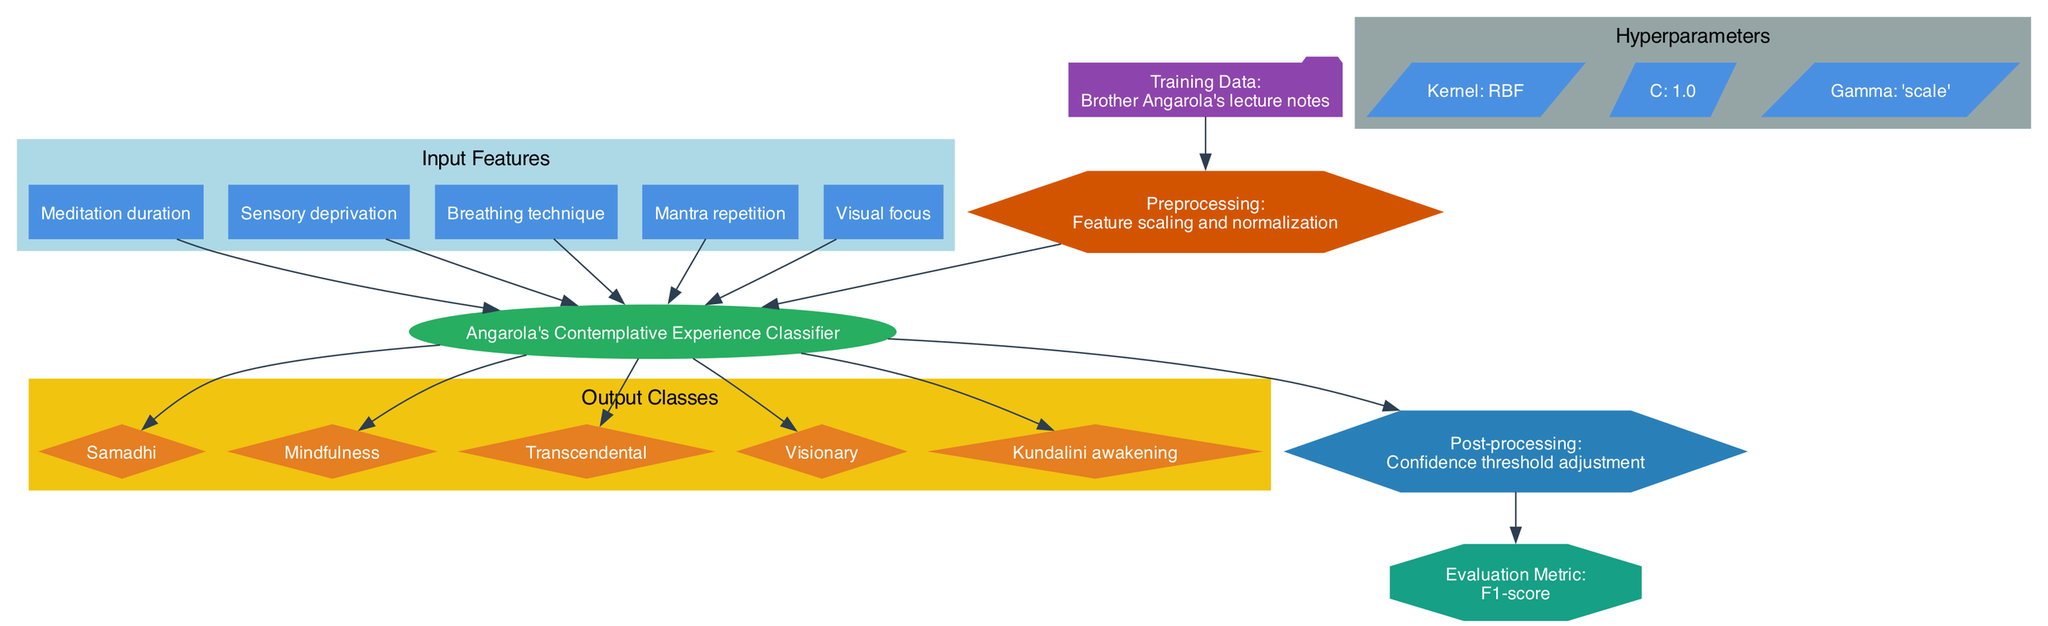What are the input features for the SVM model? The input features are provided in a cluster labeled "Input Features", which includes: Meditation duration, Sensory deprivation, Breathing technique, Mantra repetition, and Visual focus.
Answer: Meditation duration, Sensory deprivation, Breathing technique, Mantra repetition, Visual focus What is the evaluation metric used in this model? In the diagram, there is a node labeled "Evaluation Metric", which specifies that the model uses the F1-score to evaluate its performance.
Answer: F1-score How many output classes does the SVM classify? The "Output Classes" subgraph shows five distinct classes: Samadhi, Mindfulness, Transcendental, Visionary, and Kundalini awakening. Counting these gives a total of five output classes.
Answer: Five Which kernel is used in the hyperparameters? There is a node in the "Hyperparameters" section labeled "Kernel" which states that the RBF kernel is used in this SVM model.
Answer: RBF What is the flow from training data to the evaluation metric? The flow starts from the "Training Data" node, connecting to "Preprocessing", which leads to the "SVM" node. From there, it directs to "Post-processing", and finally connects to the "Evaluation Metric". This sequence describes how data moves and is processed to evaluate model performance.
Answer: Training Data -> Preprocessing -> SVM -> Post-processing -> Evaluation Metric What type of model is represented in this diagram? The model labeled "Angarola's Contemplative Experience Classifier" is identified as a support vector machine (SVM) model, which is a type of supervised machine learning model.
Answer: Support vector machine Which post-processing step is mentioned in the diagram? The "Post-processing" node in the diagram specifies "Confidence threshold adjustment" as the process involved after the SVM classification.
Answer: Confidence threshold adjustment How many hyperparameters are identified in the diagram? Under the "Hyperparameters" cluster, three specific hyperparameters are listed: Kernel, C, and Gamma. This indicates that there are three hyperparameters defined for this SVM model.
Answer: Three 